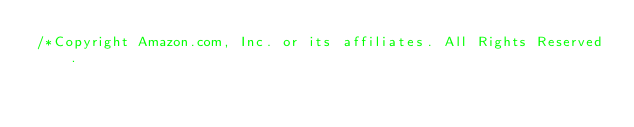Convert code to text. <code><loc_0><loc_0><loc_500><loc_500><_Java_>/*Copyright Amazon.com, Inc. or its affiliates. All Rights Reserved.</code> 